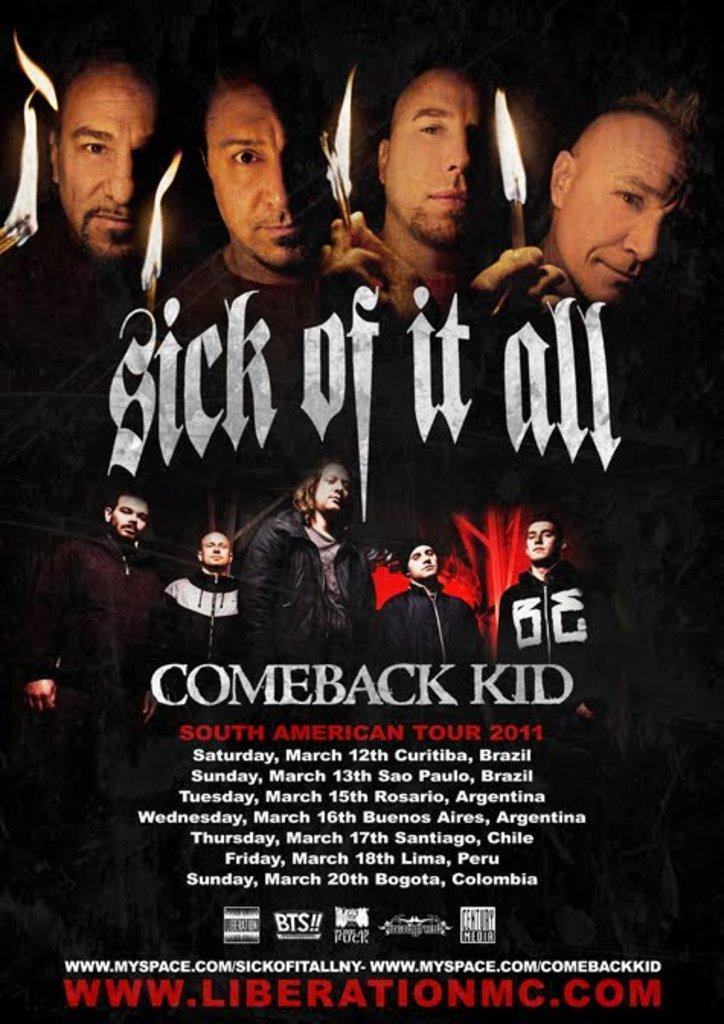What type of object is featured in the image? The image contains an advertisement poster. What are the people in the image doing? There are people holding fire in their hands. Can you describe the people in the image? There are people standing in the image. What information is provided on the poster? There is text on the poster. How many cents can be seen on the poster in the image? There is no mention of cents or currency on the poster in the image. What type of hose is being used by the people in the image? There is no hose present in the image; the people are holding fire in their hands. 